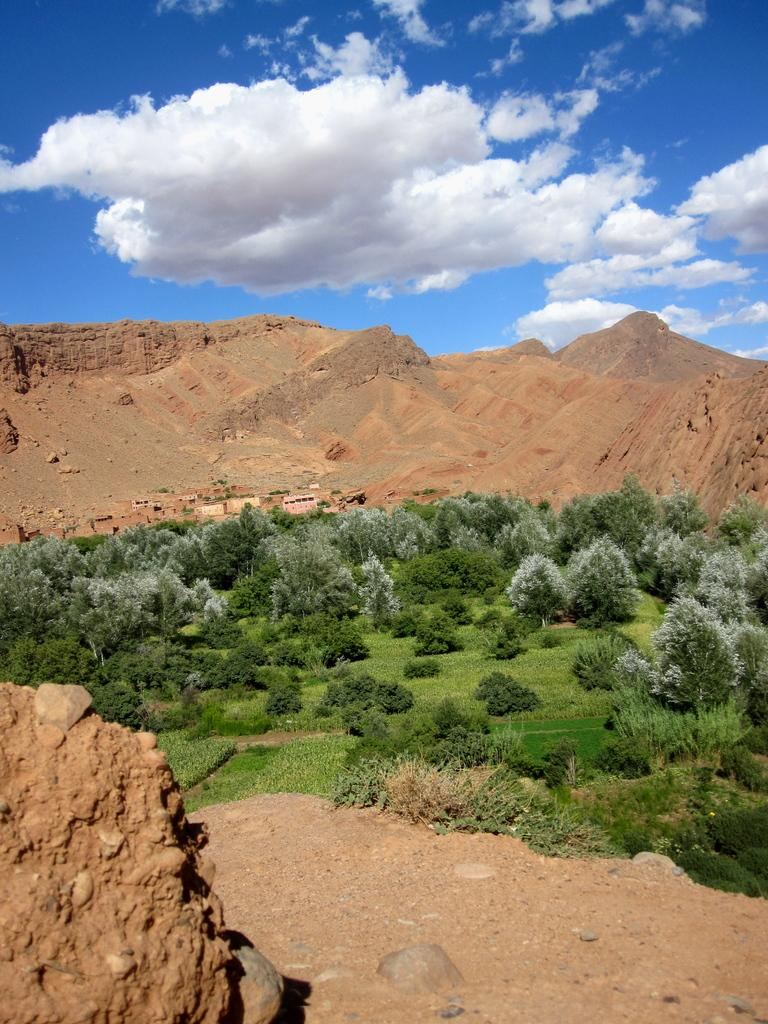What type of vegetation can be seen in the image? There are trees, plants, and grass visible in the image. What geographical feature can be seen in the distance? There are mountains visible in the image. What is the condition of the sky in the image? The sky is cloudy in the image. What sound does the heart of the aunt make in the image? There is no sound, heart, or aunt present in the image. 